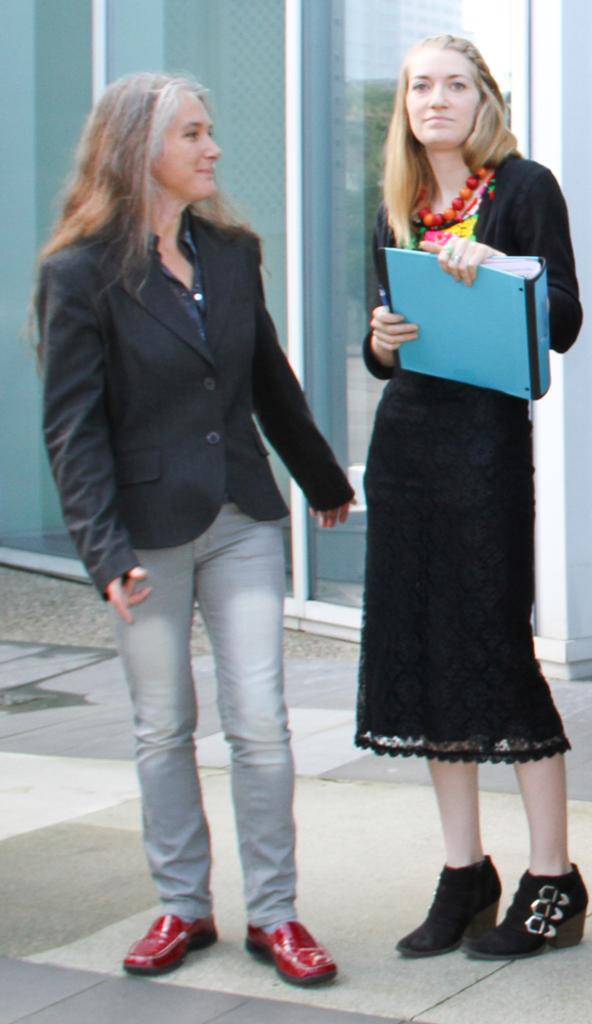How many people are in the image? There are two persons in the image. What is the lady holding in her hand? The lady is holding an object in her hand. On which side of the image is the lady located? The lady is on the right side of the image. What can be seen in the background of the image? There are glasses of a building in the image. What type of quartz can be seen in the lady's hand in the image? There is no quartz present in the image, and the lady is holding an object, not quartz. How does the lady increase her speed while holding the object in the image? The lady is not depicted as moving or changing her speed in the image. 